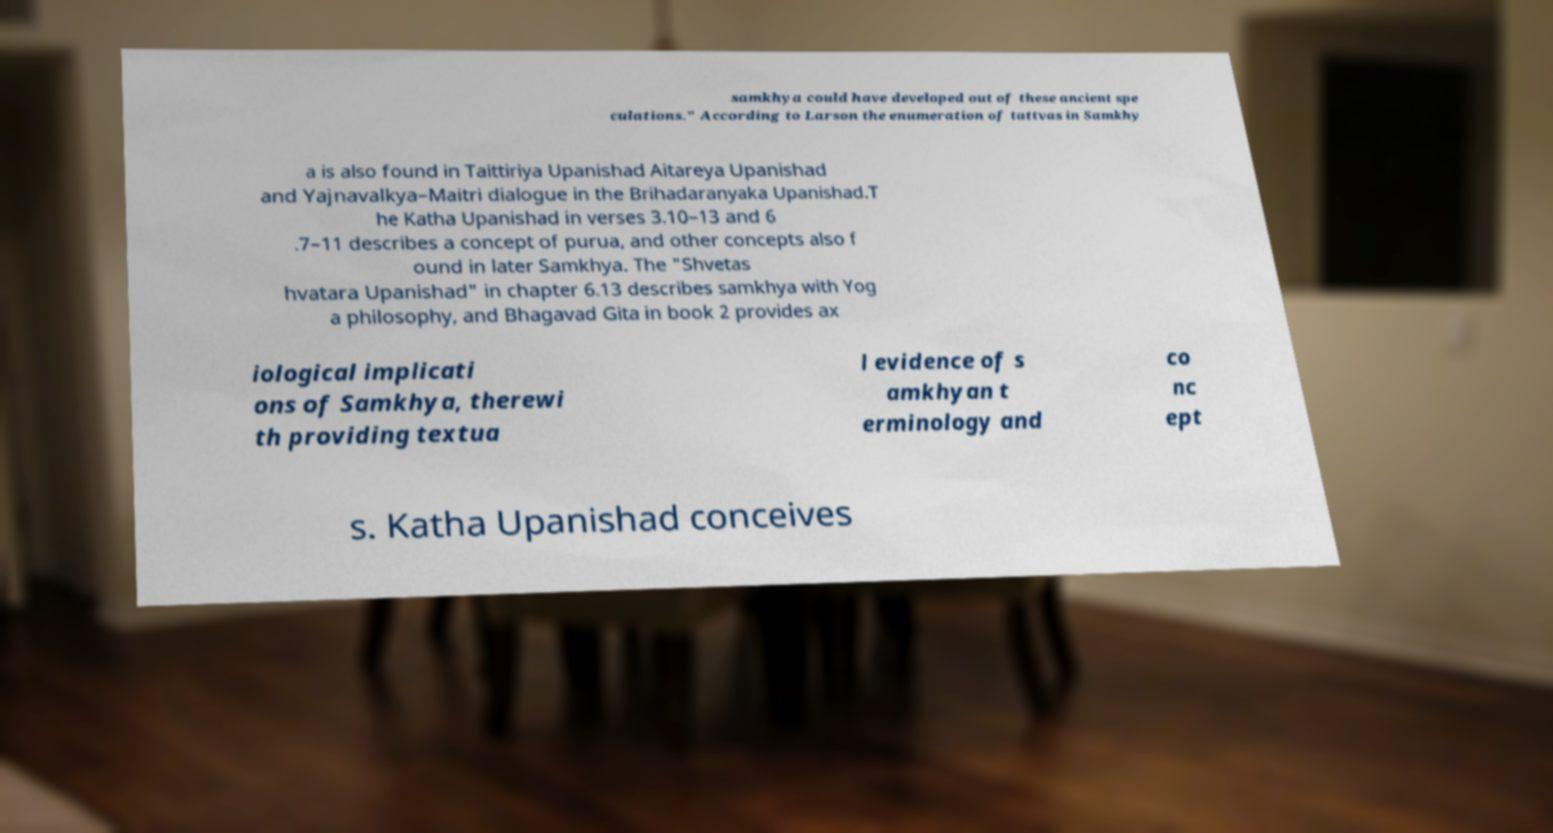Could you extract and type out the text from this image? samkhya could have developed out of these ancient spe culations." According to Larson the enumeration of tattvas in Samkhy a is also found in Taittiriya Upanishad Aitareya Upanishad and Yajnavalkya–Maitri dialogue in the Brihadaranyaka Upanishad.T he Katha Upanishad in verses 3.10–13 and 6 .7–11 describes a concept of purua, and other concepts also f ound in later Samkhya. The "Shvetas hvatara Upanishad" in chapter 6.13 describes samkhya with Yog a philosophy, and Bhagavad Gita in book 2 provides ax iological implicati ons of Samkhya, therewi th providing textua l evidence of s amkhyan t erminology and co nc ept s. Katha Upanishad conceives 